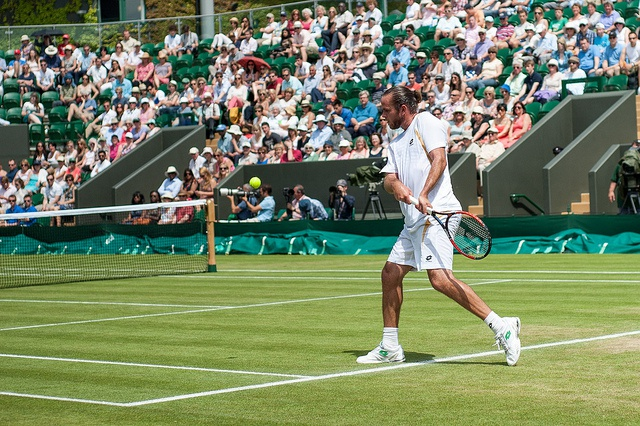Describe the objects in this image and their specific colors. I can see people in black, lightgray, gray, and lightpink tones, people in black, white, maroon, darkgray, and brown tones, chair in black, teal, darkgreen, and gray tones, tennis racket in black, white, gray, and darkgray tones, and people in black, white, lightpink, and darkgray tones in this image. 